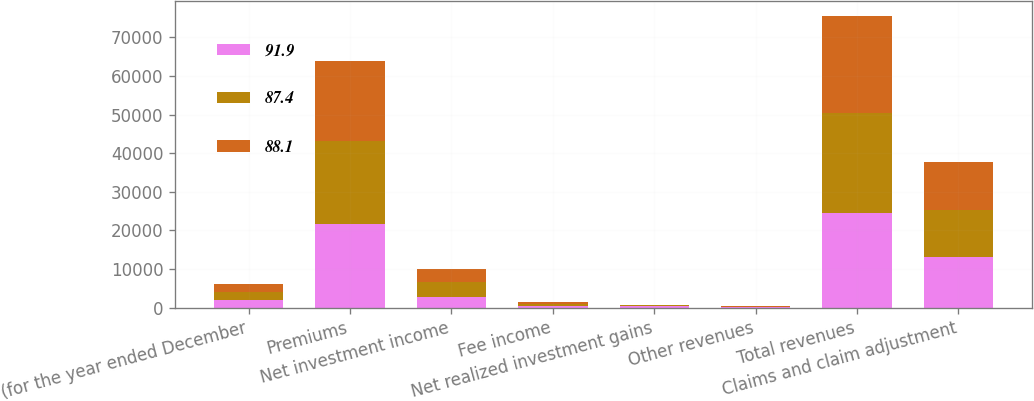Convert chart. <chart><loc_0><loc_0><loc_500><loc_500><stacked_bar_chart><ecel><fcel>(for the year ended December<fcel>Premiums<fcel>Net investment income<fcel>Fee income<fcel>Net realized investment gains<fcel>Other revenues<fcel>Total revenues<fcel>Claims and claim adjustment<nl><fcel>91.9<fcel>2008<fcel>21579<fcel>2792<fcel>390<fcel>415<fcel>131<fcel>24477<fcel>12993<nl><fcel>87.4<fcel>2007<fcel>21470<fcel>3761<fcel>508<fcel>154<fcel>124<fcel>26017<fcel>12397<nl><fcel>88.1<fcel>2006<fcel>20760<fcel>3517<fcel>591<fcel>11<fcel>211<fcel>25090<fcel>12244<nl></chart> 